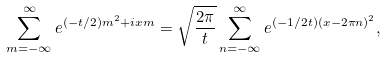<formula> <loc_0><loc_0><loc_500><loc_500>\sum _ { m = - \infty } ^ { \infty } e ^ { ( - t / 2 ) m ^ { 2 } + i x m } = \sqrt { \frac { 2 \pi } { t } } \sum _ { n = - \infty } ^ { \infty } e ^ { ( - 1 / 2 t ) ( x - 2 \pi n ) ^ { 2 } } ,</formula> 